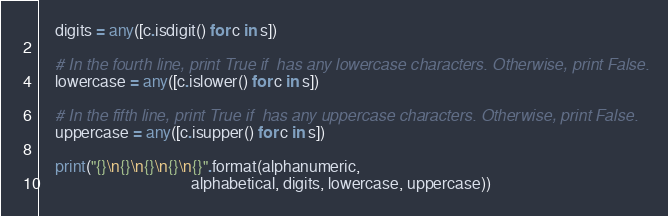<code> <loc_0><loc_0><loc_500><loc_500><_Python_>    digits = any([c.isdigit() for c in s])

    # In the fourth line, print True if  has any lowercase characters. Otherwise, print False.
    lowercase = any([c.islower() for c in s])

    # In the fifth line, print True if  has any uppercase characters. Otherwise, print False.
    uppercase = any([c.isupper() for c in s])

    print("{}\n{}\n{}\n{}\n{}".format(alphanumeric,
                                      alphabetical, digits, lowercase, uppercase))
</code> 